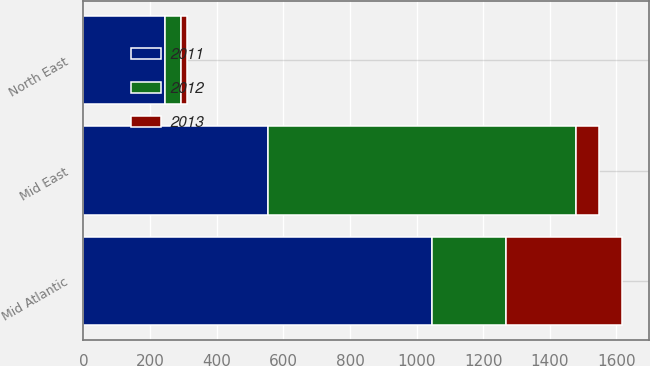Convert chart to OTSL. <chart><loc_0><loc_0><loc_500><loc_500><stacked_bar_chart><ecel><fcel>Mid Atlantic<fcel>North East<fcel>Mid East<nl><fcel>2012<fcel>222<fcel>47<fcel>923<nl><fcel>2013<fcel>349<fcel>19<fcel>72<nl><fcel>2011<fcel>1045<fcel>246<fcel>554<nl></chart> 